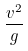Convert formula to latex. <formula><loc_0><loc_0><loc_500><loc_500>\frac { v ^ { 2 } } { g }</formula> 